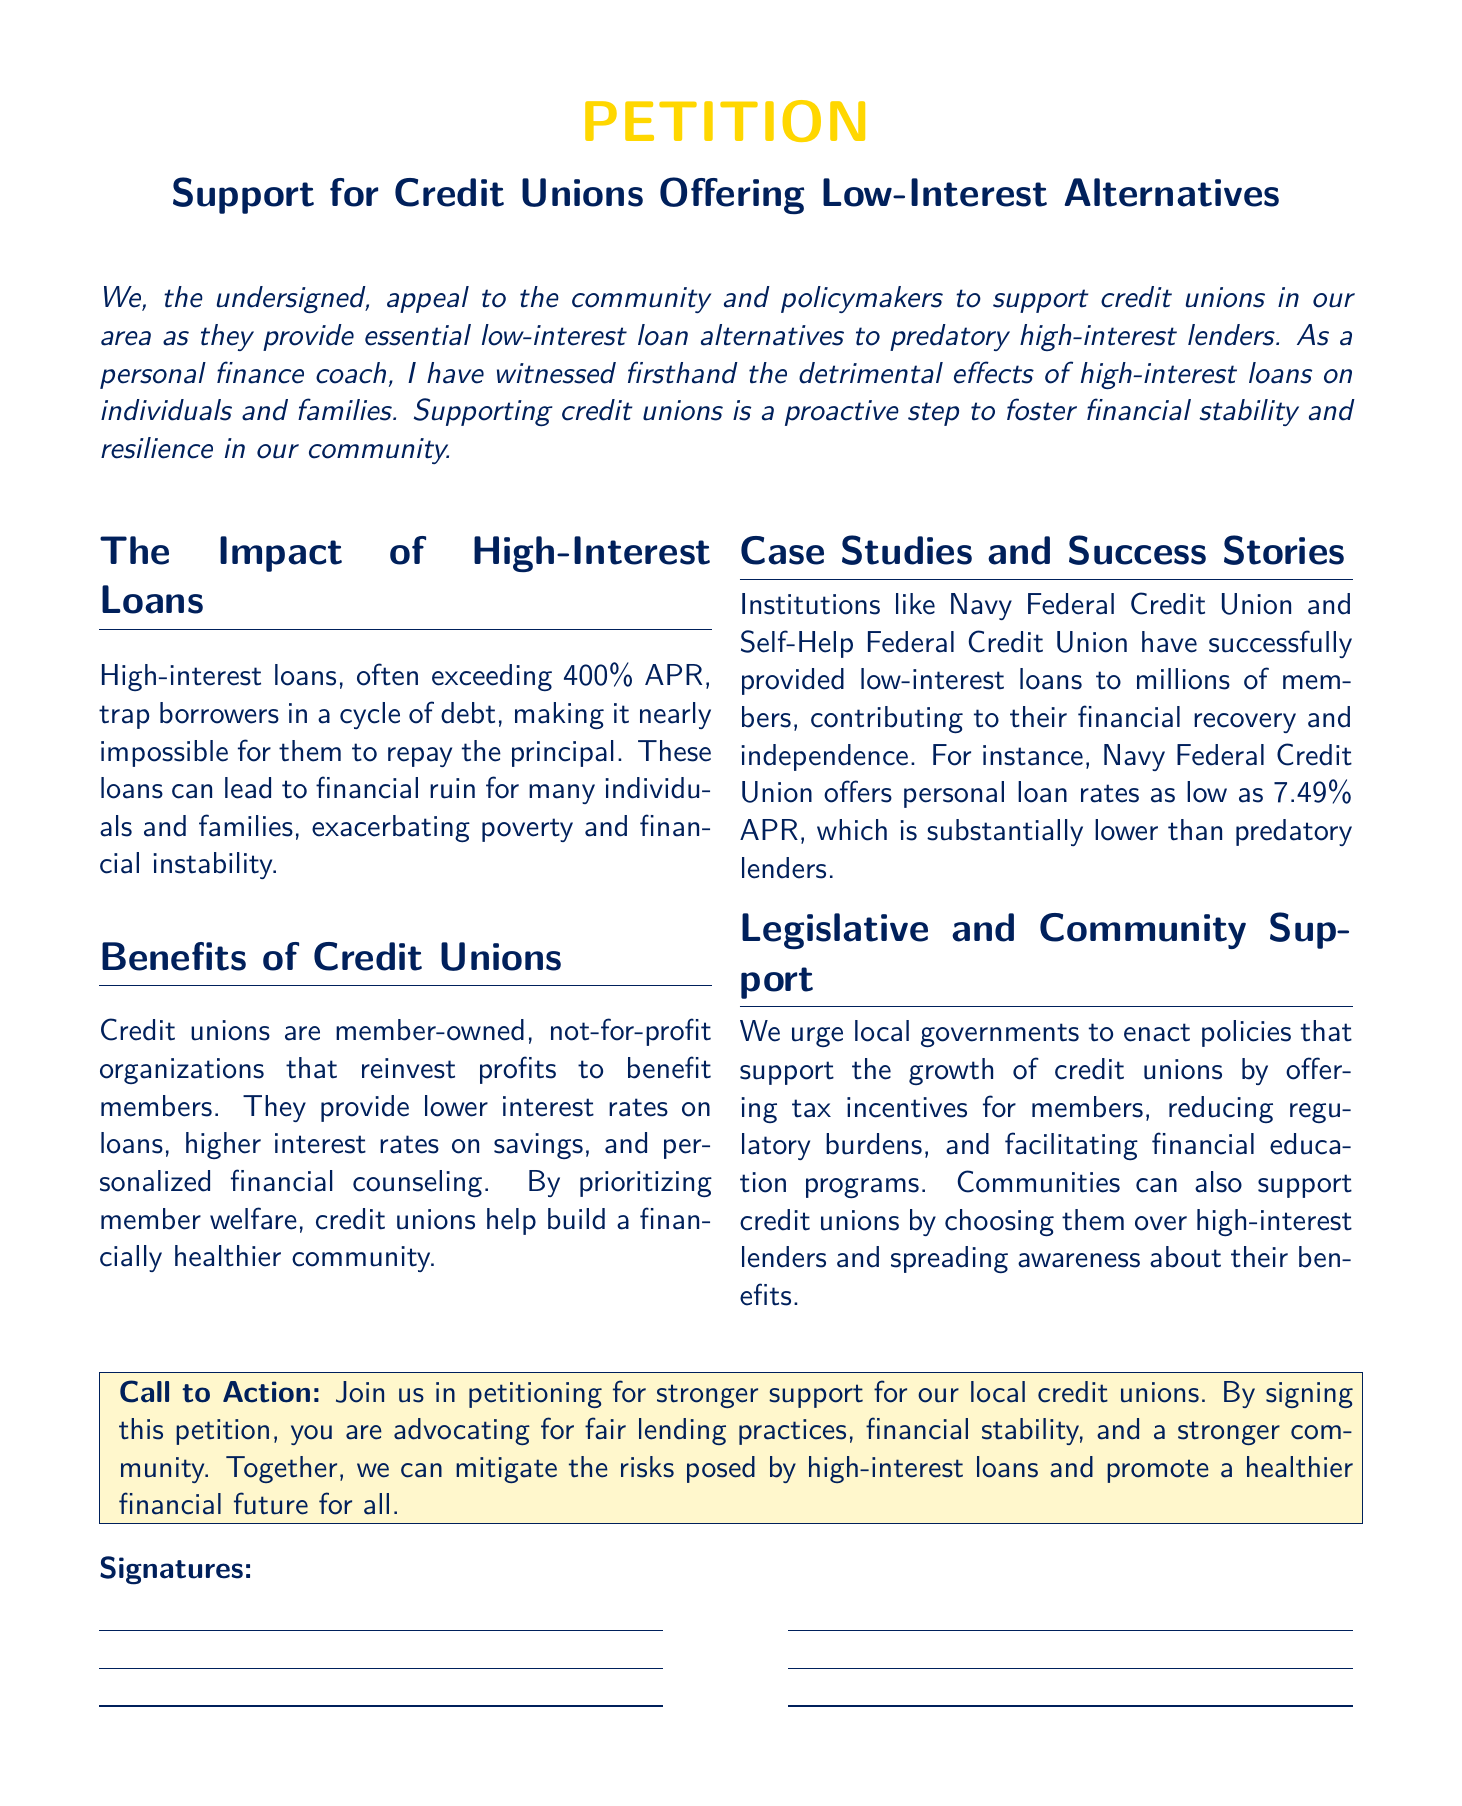What is the main purpose of the petition? The petition aims to garner support for credit unions providing low-interest loan alternatives to high-interest lenders.
Answer: Support for credit unions offering low-interest alternatives What is the maximum APR mentioned for high-interest loans? The document notes that high-interest loans often exceed this percentage, indicating the extreme burden they place on borrowers.
Answer: 400% What type of organizations are credit unions? The document describes credit unions as organizations that are owned by their members.
Answer: Member-owned What is the interest rate for personal loans at Navy Federal Credit Union? The document provides a specific range for personal loan rates, showcasing the advantage they offer over high-interest lenders.
Answer: 7.49% What type of support is urged from local governments? The petition calls for specific measures that would enhance the viability and presence of credit unions in the community.
Answer: Tax incentives What do credit unions prioritize according to the petition? This element of the document highlights the foundational goal of credit unions in contrast to high-interest lenders.
Answer: Member welfare What are the community actions suggested in the document? The petition advises on specific actions that individuals can take to strengthen the role of credit unions in financial practices.
Answer: Choose credit unions over high-interest lenders What is the title of the petition? The title encapsulates the focus of the petition regarding financial alternatives.
Answer: Support for Credit Unions Offering Low-Interest Alternatives How are high-interest loans described in the petition? This description provides insight into the consequences of such loans for individuals and families.
Answer: Predatory 